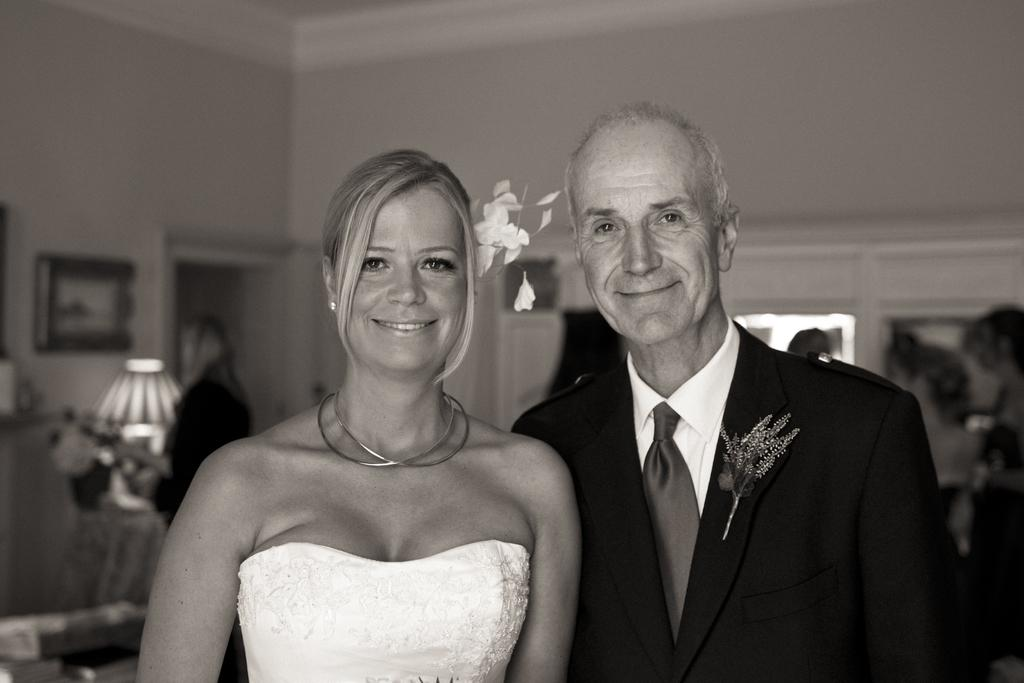What are the people in the image doing? The people in the image are standing and smiling. Can you describe the background of the image? The background of the image is blurry, and there are people, a wall, and objects visible. How many people can be seen in the image? There are people standing in the foreground and visible in the background, but the exact number cannot be determined from the provided facts. Where are the kittens playing in the image? There are no kittens present in the image. What type of air is visible in the image? There is no specific type of air visible in the image; it is simply the atmosphere surrounding the subjects and objects. 